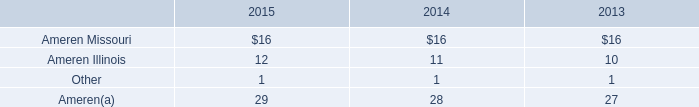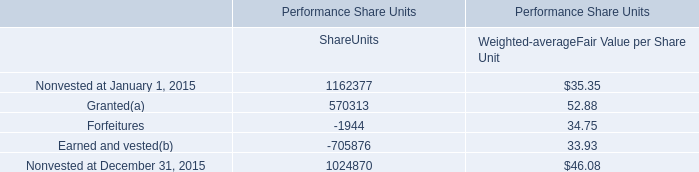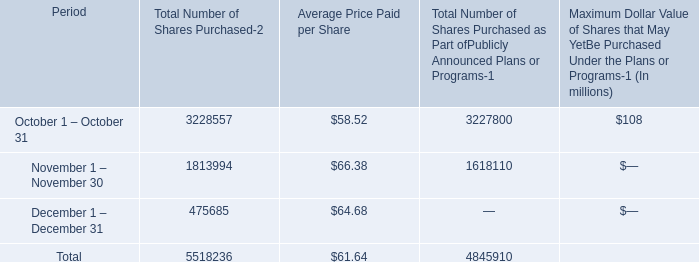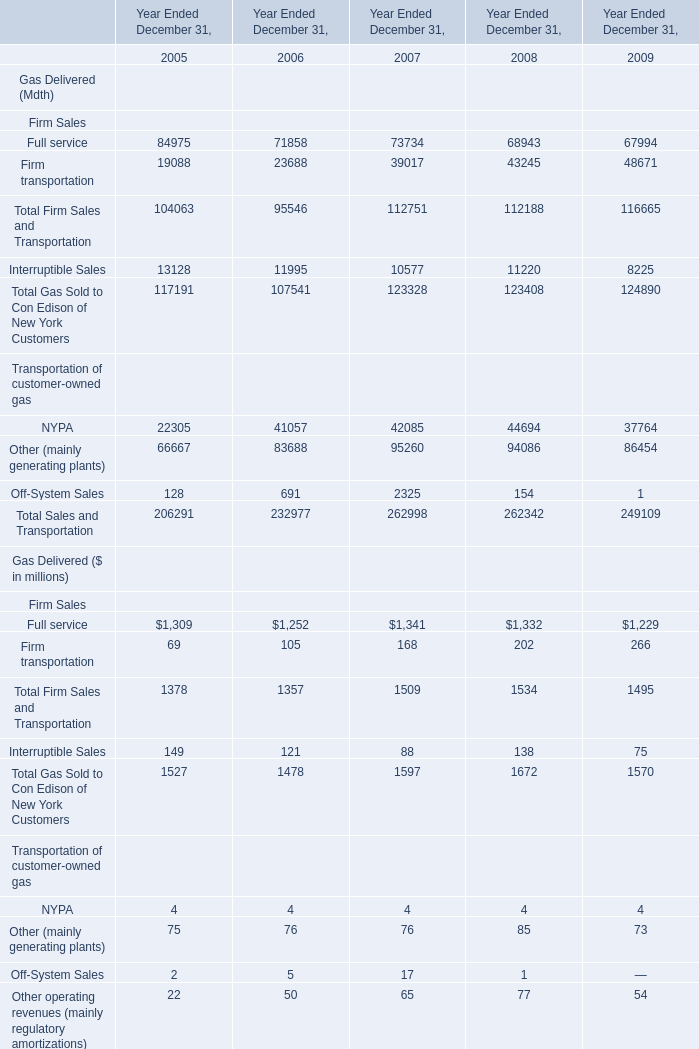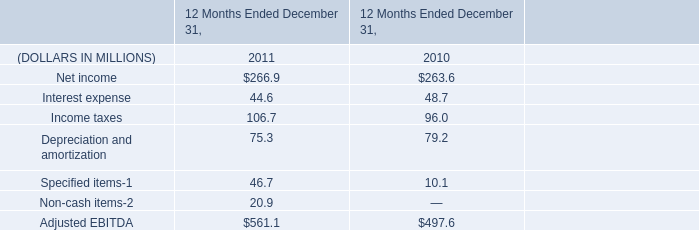what's the total amount of Nonvested at December 31, 2015 of Performance Share Units ShareUnits, and Full service Firm Sales of Year Ended December 31, 2009 ? 
Computations: (1024870.0 + 1229.0)
Answer: 1026099.0. What's the sum of Nonvested at December 31, 2015 of Performance Share Units ShareUnits, and Full service Firm Sales of Year Ended December 31, 2008 ? 
Computations: (1024870.0 + 1332.0)
Answer: 1026202.0. What's the sum of Full service Firm Sales of Year Ended December 31, 2008, Nonvested at January 1, 2015 of Performance Share Units ShareUnits, and Total Gas Sold to Con Edison of New York Customers of Year Ended December 31, 2009 ? 
Computations: ((1332.0 + 1162377.0) + 124890.0)
Answer: 1288599.0. 